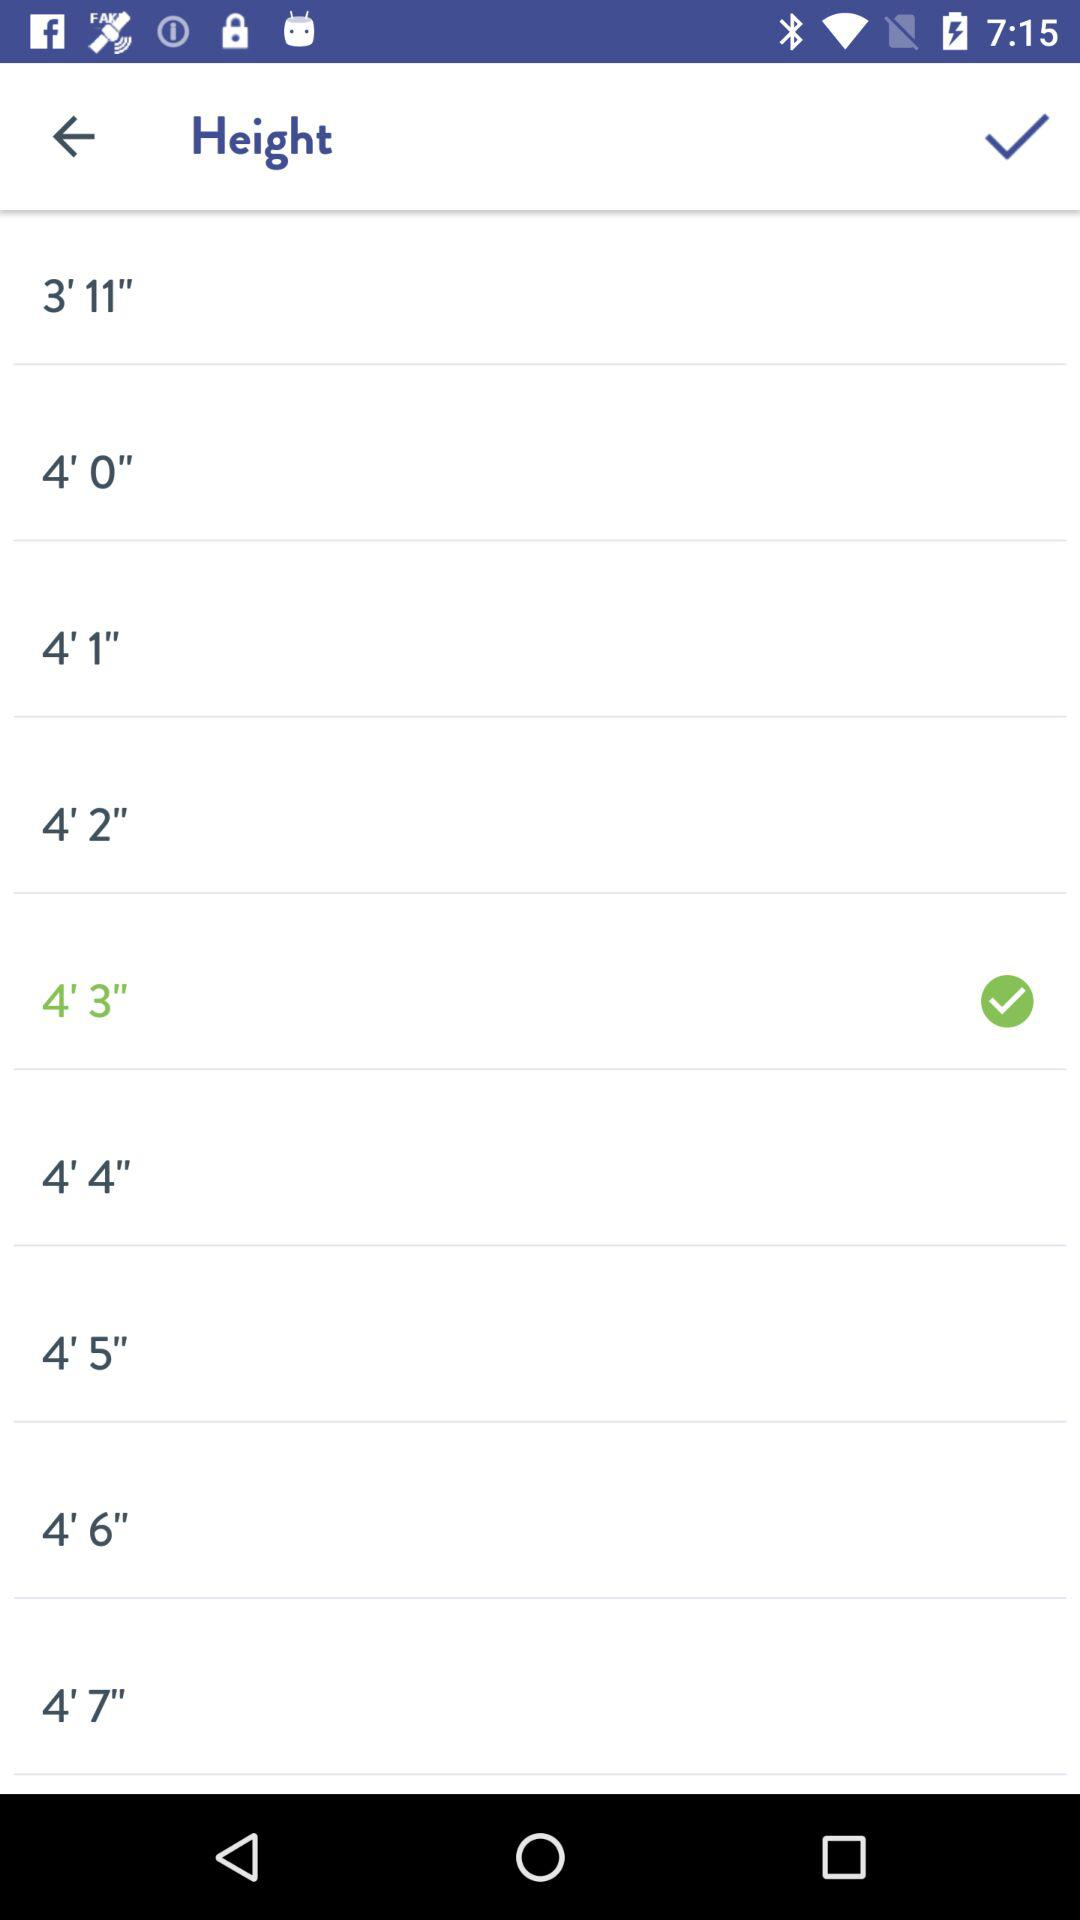How much is the selected height in meters?
When the provided information is insufficient, respond with <no answer>. <no answer> 